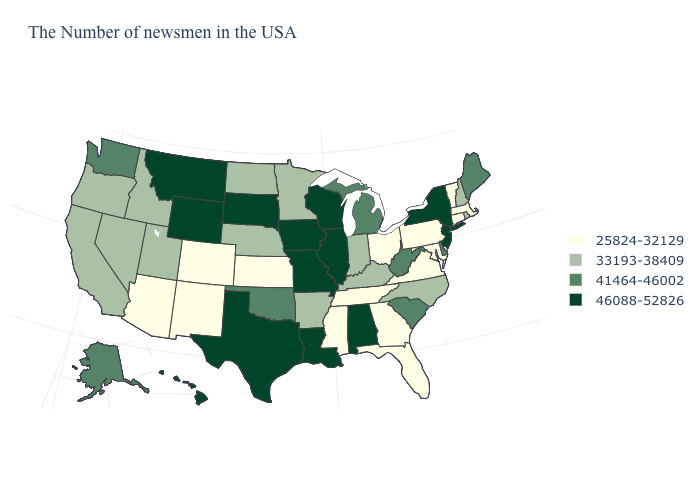What is the lowest value in the USA?
Answer briefly. 25824-32129. Which states have the lowest value in the MidWest?
Short answer required. Ohio, Kansas. What is the value of South Carolina?
Write a very short answer. 41464-46002. Name the states that have a value in the range 46088-52826?
Short answer required. New York, New Jersey, Alabama, Wisconsin, Illinois, Louisiana, Missouri, Iowa, Texas, South Dakota, Wyoming, Montana, Hawaii. What is the value of Texas?
Keep it brief. 46088-52826. What is the lowest value in the USA?
Give a very brief answer. 25824-32129. What is the lowest value in states that border Kansas?
Write a very short answer. 25824-32129. What is the value of Michigan?
Answer briefly. 41464-46002. What is the value of Georgia?
Write a very short answer. 25824-32129. Name the states that have a value in the range 33193-38409?
Quick response, please. Rhode Island, New Hampshire, North Carolina, Kentucky, Indiana, Arkansas, Minnesota, Nebraska, North Dakota, Utah, Idaho, Nevada, California, Oregon. Among the states that border Colorado , which have the lowest value?
Be succinct. Kansas, New Mexico, Arizona. Name the states that have a value in the range 46088-52826?
Write a very short answer. New York, New Jersey, Alabama, Wisconsin, Illinois, Louisiana, Missouri, Iowa, Texas, South Dakota, Wyoming, Montana, Hawaii. What is the lowest value in the South?
Concise answer only. 25824-32129. Does the first symbol in the legend represent the smallest category?
Answer briefly. Yes. What is the highest value in states that border Massachusetts?
Answer briefly. 46088-52826. 